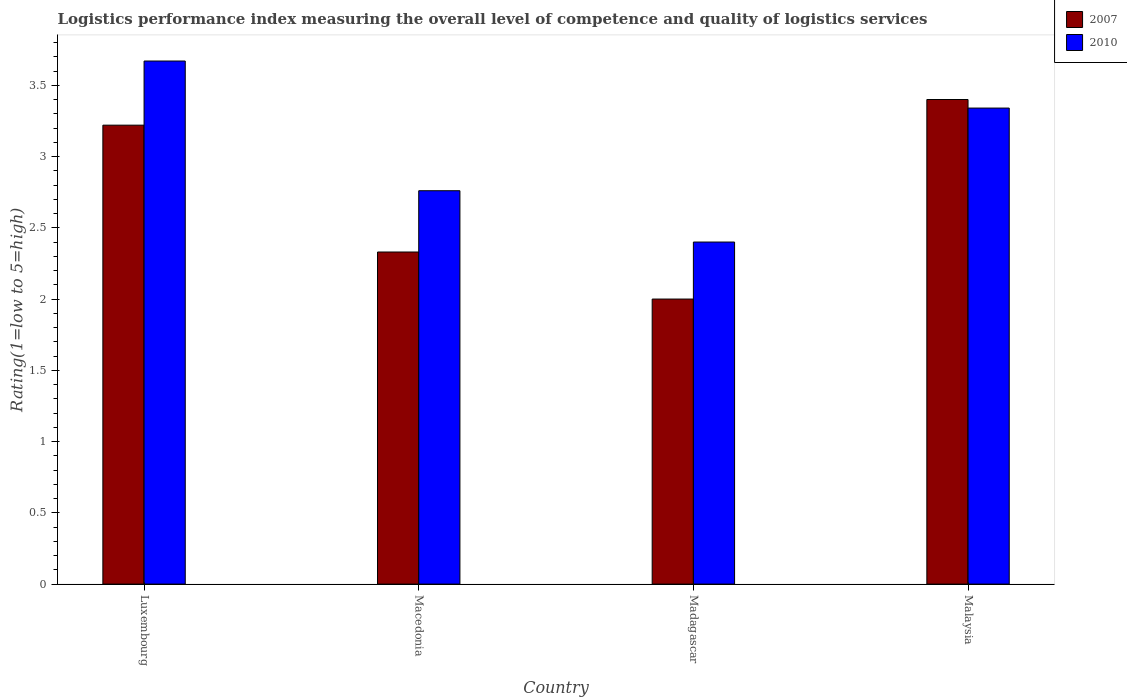How many groups of bars are there?
Keep it short and to the point. 4. Are the number of bars on each tick of the X-axis equal?
Offer a very short reply. Yes. How many bars are there on the 4th tick from the left?
Offer a terse response. 2. How many bars are there on the 4th tick from the right?
Your response must be concise. 2. What is the label of the 1st group of bars from the left?
Keep it short and to the point. Luxembourg. What is the Logistic performance index in 2007 in Madagascar?
Make the answer very short. 2. In which country was the Logistic performance index in 2010 maximum?
Your answer should be very brief. Luxembourg. In which country was the Logistic performance index in 2007 minimum?
Your answer should be very brief. Madagascar. What is the total Logistic performance index in 2007 in the graph?
Your answer should be very brief. 10.95. What is the difference between the Logistic performance index in 2007 in Luxembourg and that in Macedonia?
Your response must be concise. 0.89. What is the average Logistic performance index in 2010 per country?
Offer a very short reply. 3.04. What is the difference between the Logistic performance index of/in 2007 and Logistic performance index of/in 2010 in Malaysia?
Provide a short and direct response. 0.06. What is the ratio of the Logistic performance index in 2010 in Macedonia to that in Malaysia?
Make the answer very short. 0.83. Is the difference between the Logistic performance index in 2007 in Luxembourg and Madagascar greater than the difference between the Logistic performance index in 2010 in Luxembourg and Madagascar?
Offer a very short reply. No. What is the difference between the highest and the second highest Logistic performance index in 2010?
Make the answer very short. 0.58. What is the difference between the highest and the lowest Logistic performance index in 2007?
Provide a succinct answer. 1.4. In how many countries, is the Logistic performance index in 2007 greater than the average Logistic performance index in 2007 taken over all countries?
Your response must be concise. 2. Is the sum of the Logistic performance index in 2007 in Luxembourg and Madagascar greater than the maximum Logistic performance index in 2010 across all countries?
Offer a very short reply. Yes. What does the 1st bar from the left in Luxembourg represents?
Provide a short and direct response. 2007. Does the graph contain any zero values?
Ensure brevity in your answer.  No. Does the graph contain grids?
Your answer should be very brief. No. Where does the legend appear in the graph?
Your answer should be compact. Top right. How many legend labels are there?
Provide a succinct answer. 2. How are the legend labels stacked?
Provide a short and direct response. Vertical. What is the title of the graph?
Provide a short and direct response. Logistics performance index measuring the overall level of competence and quality of logistics services. Does "1996" appear as one of the legend labels in the graph?
Provide a succinct answer. No. What is the label or title of the Y-axis?
Give a very brief answer. Rating(1=low to 5=high). What is the Rating(1=low to 5=high) in 2007 in Luxembourg?
Offer a terse response. 3.22. What is the Rating(1=low to 5=high) in 2010 in Luxembourg?
Provide a short and direct response. 3.67. What is the Rating(1=low to 5=high) of 2007 in Macedonia?
Make the answer very short. 2.33. What is the Rating(1=low to 5=high) in 2010 in Macedonia?
Your answer should be very brief. 2.76. What is the Rating(1=low to 5=high) in 2010 in Malaysia?
Provide a short and direct response. 3.34. Across all countries, what is the maximum Rating(1=low to 5=high) in 2010?
Provide a succinct answer. 3.67. What is the total Rating(1=low to 5=high) in 2007 in the graph?
Offer a very short reply. 10.95. What is the total Rating(1=low to 5=high) in 2010 in the graph?
Give a very brief answer. 12.17. What is the difference between the Rating(1=low to 5=high) of 2007 in Luxembourg and that in Macedonia?
Your answer should be very brief. 0.89. What is the difference between the Rating(1=low to 5=high) of 2010 in Luxembourg and that in Macedonia?
Offer a very short reply. 0.91. What is the difference between the Rating(1=low to 5=high) of 2007 in Luxembourg and that in Madagascar?
Your answer should be compact. 1.22. What is the difference between the Rating(1=low to 5=high) in 2010 in Luxembourg and that in Madagascar?
Your response must be concise. 1.27. What is the difference between the Rating(1=low to 5=high) in 2007 in Luxembourg and that in Malaysia?
Provide a succinct answer. -0.18. What is the difference between the Rating(1=low to 5=high) of 2010 in Luxembourg and that in Malaysia?
Make the answer very short. 0.33. What is the difference between the Rating(1=low to 5=high) in 2007 in Macedonia and that in Madagascar?
Offer a terse response. 0.33. What is the difference between the Rating(1=low to 5=high) of 2010 in Macedonia and that in Madagascar?
Offer a terse response. 0.36. What is the difference between the Rating(1=low to 5=high) of 2007 in Macedonia and that in Malaysia?
Your answer should be compact. -1.07. What is the difference between the Rating(1=low to 5=high) in 2010 in Macedonia and that in Malaysia?
Your answer should be very brief. -0.58. What is the difference between the Rating(1=low to 5=high) in 2010 in Madagascar and that in Malaysia?
Give a very brief answer. -0.94. What is the difference between the Rating(1=low to 5=high) in 2007 in Luxembourg and the Rating(1=low to 5=high) in 2010 in Macedonia?
Your answer should be very brief. 0.46. What is the difference between the Rating(1=low to 5=high) of 2007 in Luxembourg and the Rating(1=low to 5=high) of 2010 in Madagascar?
Provide a short and direct response. 0.82. What is the difference between the Rating(1=low to 5=high) in 2007 in Luxembourg and the Rating(1=low to 5=high) in 2010 in Malaysia?
Your answer should be very brief. -0.12. What is the difference between the Rating(1=low to 5=high) in 2007 in Macedonia and the Rating(1=low to 5=high) in 2010 in Madagascar?
Keep it short and to the point. -0.07. What is the difference between the Rating(1=low to 5=high) of 2007 in Macedonia and the Rating(1=low to 5=high) of 2010 in Malaysia?
Offer a very short reply. -1.01. What is the difference between the Rating(1=low to 5=high) of 2007 in Madagascar and the Rating(1=low to 5=high) of 2010 in Malaysia?
Keep it short and to the point. -1.34. What is the average Rating(1=low to 5=high) in 2007 per country?
Give a very brief answer. 2.74. What is the average Rating(1=low to 5=high) in 2010 per country?
Provide a short and direct response. 3.04. What is the difference between the Rating(1=low to 5=high) of 2007 and Rating(1=low to 5=high) of 2010 in Luxembourg?
Your answer should be very brief. -0.45. What is the difference between the Rating(1=low to 5=high) in 2007 and Rating(1=low to 5=high) in 2010 in Macedonia?
Offer a very short reply. -0.43. What is the difference between the Rating(1=low to 5=high) of 2007 and Rating(1=low to 5=high) of 2010 in Madagascar?
Make the answer very short. -0.4. What is the ratio of the Rating(1=low to 5=high) of 2007 in Luxembourg to that in Macedonia?
Offer a very short reply. 1.38. What is the ratio of the Rating(1=low to 5=high) in 2010 in Luxembourg to that in Macedonia?
Provide a succinct answer. 1.33. What is the ratio of the Rating(1=low to 5=high) of 2007 in Luxembourg to that in Madagascar?
Provide a short and direct response. 1.61. What is the ratio of the Rating(1=low to 5=high) in 2010 in Luxembourg to that in Madagascar?
Make the answer very short. 1.53. What is the ratio of the Rating(1=low to 5=high) in 2007 in Luxembourg to that in Malaysia?
Offer a very short reply. 0.95. What is the ratio of the Rating(1=low to 5=high) in 2010 in Luxembourg to that in Malaysia?
Give a very brief answer. 1.1. What is the ratio of the Rating(1=low to 5=high) in 2007 in Macedonia to that in Madagascar?
Provide a succinct answer. 1.17. What is the ratio of the Rating(1=low to 5=high) in 2010 in Macedonia to that in Madagascar?
Offer a very short reply. 1.15. What is the ratio of the Rating(1=low to 5=high) of 2007 in Macedonia to that in Malaysia?
Give a very brief answer. 0.69. What is the ratio of the Rating(1=low to 5=high) of 2010 in Macedonia to that in Malaysia?
Provide a short and direct response. 0.83. What is the ratio of the Rating(1=low to 5=high) in 2007 in Madagascar to that in Malaysia?
Keep it short and to the point. 0.59. What is the ratio of the Rating(1=low to 5=high) in 2010 in Madagascar to that in Malaysia?
Ensure brevity in your answer.  0.72. What is the difference between the highest and the second highest Rating(1=low to 5=high) in 2007?
Ensure brevity in your answer.  0.18. What is the difference between the highest and the second highest Rating(1=low to 5=high) of 2010?
Provide a succinct answer. 0.33. What is the difference between the highest and the lowest Rating(1=low to 5=high) of 2010?
Provide a succinct answer. 1.27. 